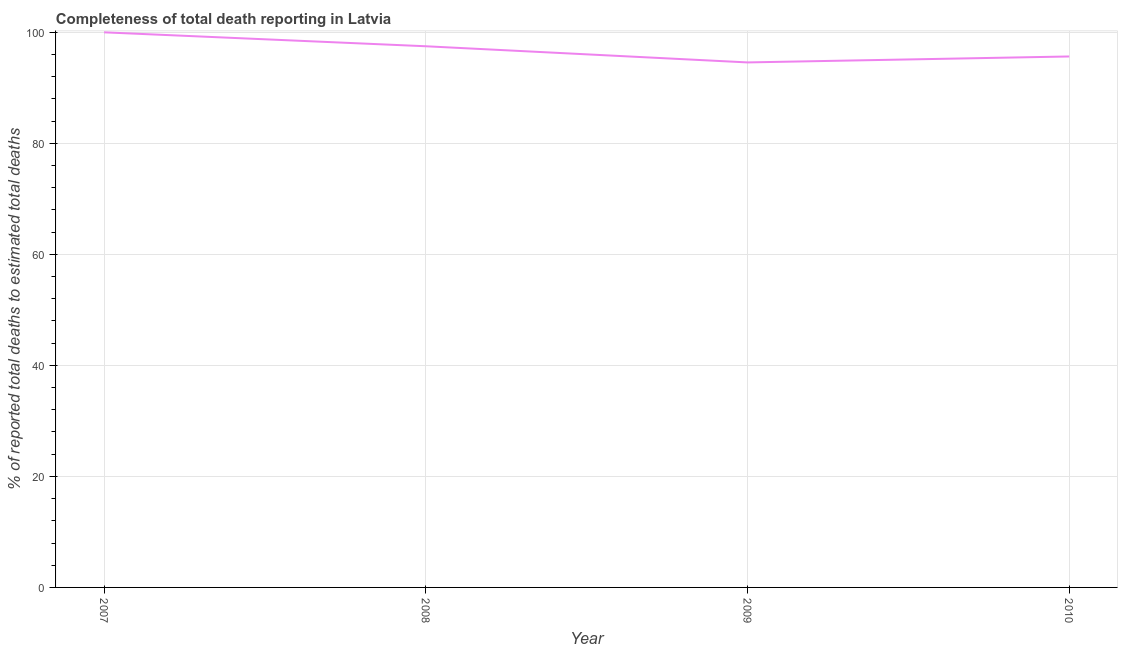What is the completeness of total death reports in 2010?
Keep it short and to the point. 95.65. Across all years, what is the maximum completeness of total death reports?
Provide a succinct answer. 100. Across all years, what is the minimum completeness of total death reports?
Provide a short and direct response. 94.58. In which year was the completeness of total death reports minimum?
Ensure brevity in your answer.  2009. What is the sum of the completeness of total death reports?
Provide a succinct answer. 387.72. What is the difference between the completeness of total death reports in 2008 and 2010?
Offer a terse response. 1.84. What is the average completeness of total death reports per year?
Your answer should be compact. 96.93. What is the median completeness of total death reports?
Keep it short and to the point. 96.57. What is the ratio of the completeness of total death reports in 2008 to that in 2009?
Your answer should be compact. 1.03. Is the completeness of total death reports in 2009 less than that in 2010?
Provide a succinct answer. Yes. What is the difference between the highest and the second highest completeness of total death reports?
Ensure brevity in your answer.  2.51. Is the sum of the completeness of total death reports in 2007 and 2009 greater than the maximum completeness of total death reports across all years?
Your response must be concise. Yes. What is the difference between the highest and the lowest completeness of total death reports?
Make the answer very short. 5.42. In how many years, is the completeness of total death reports greater than the average completeness of total death reports taken over all years?
Offer a very short reply. 2. What is the difference between two consecutive major ticks on the Y-axis?
Provide a succinct answer. 20. Are the values on the major ticks of Y-axis written in scientific E-notation?
Provide a succinct answer. No. Does the graph contain any zero values?
Ensure brevity in your answer.  No. Does the graph contain grids?
Make the answer very short. Yes. What is the title of the graph?
Offer a very short reply. Completeness of total death reporting in Latvia. What is the label or title of the X-axis?
Your response must be concise. Year. What is the label or title of the Y-axis?
Provide a succinct answer. % of reported total deaths to estimated total deaths. What is the % of reported total deaths to estimated total deaths in 2007?
Keep it short and to the point. 100. What is the % of reported total deaths to estimated total deaths of 2008?
Offer a terse response. 97.49. What is the % of reported total deaths to estimated total deaths of 2009?
Make the answer very short. 94.58. What is the % of reported total deaths to estimated total deaths in 2010?
Provide a succinct answer. 95.65. What is the difference between the % of reported total deaths to estimated total deaths in 2007 and 2008?
Provide a succinct answer. 2.51. What is the difference between the % of reported total deaths to estimated total deaths in 2007 and 2009?
Your response must be concise. 5.42. What is the difference between the % of reported total deaths to estimated total deaths in 2007 and 2010?
Keep it short and to the point. 4.35. What is the difference between the % of reported total deaths to estimated total deaths in 2008 and 2009?
Give a very brief answer. 2.91. What is the difference between the % of reported total deaths to estimated total deaths in 2008 and 2010?
Keep it short and to the point. 1.84. What is the difference between the % of reported total deaths to estimated total deaths in 2009 and 2010?
Keep it short and to the point. -1.07. What is the ratio of the % of reported total deaths to estimated total deaths in 2007 to that in 2009?
Provide a succinct answer. 1.06. What is the ratio of the % of reported total deaths to estimated total deaths in 2007 to that in 2010?
Your answer should be compact. 1.04. What is the ratio of the % of reported total deaths to estimated total deaths in 2008 to that in 2009?
Offer a terse response. 1.03. What is the ratio of the % of reported total deaths to estimated total deaths in 2008 to that in 2010?
Ensure brevity in your answer.  1.02. What is the ratio of the % of reported total deaths to estimated total deaths in 2009 to that in 2010?
Provide a short and direct response. 0.99. 